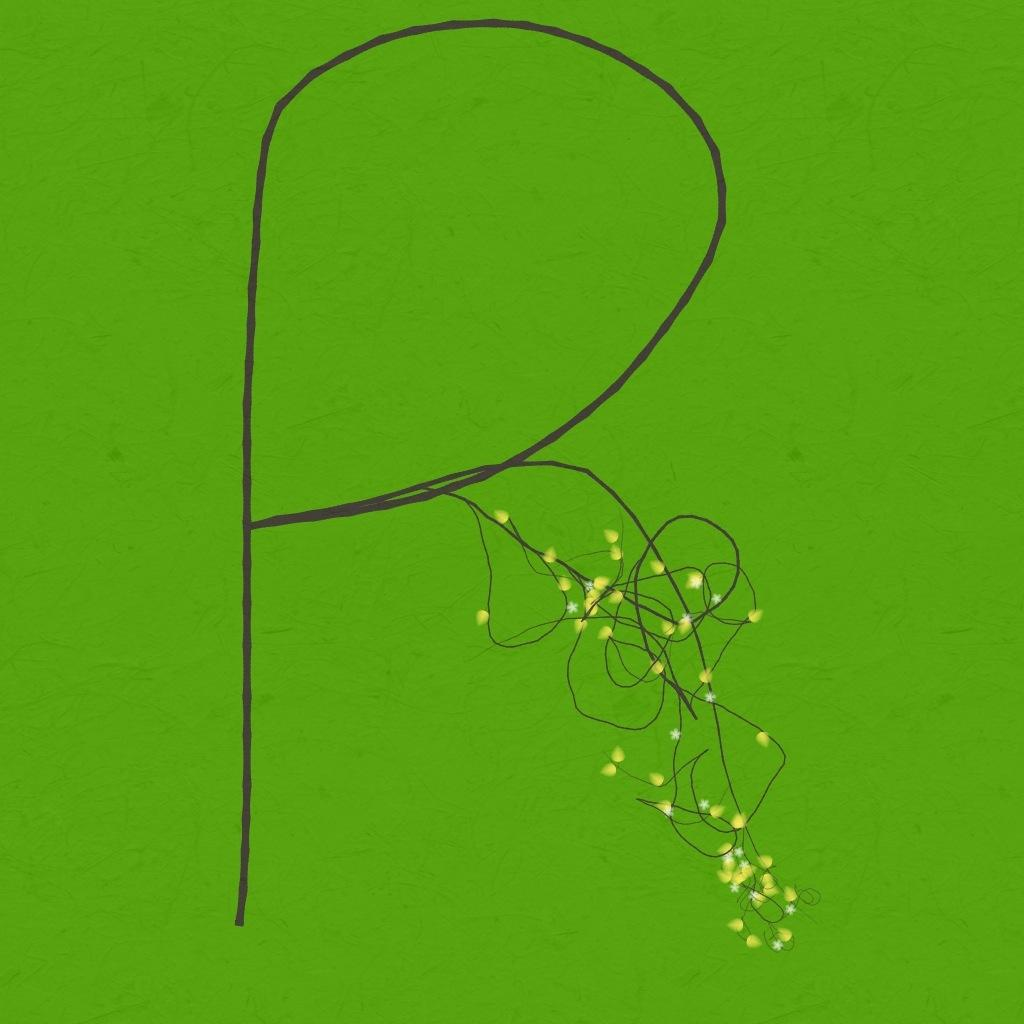What type of paper is visible in the image? There is a green paper in the image. What is depicted on the paper? There is a small craft drawing on the paper. What color is the drawing done with? The drawing is done with a black sketch. What type of invention is being showcased in the drawing on the paper? There is no invention depicted in the drawing on the paper; it is a small craft drawing. 